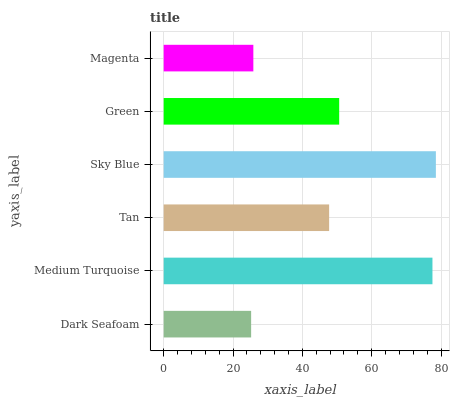Is Dark Seafoam the minimum?
Answer yes or no. Yes. Is Sky Blue the maximum?
Answer yes or no. Yes. Is Medium Turquoise the minimum?
Answer yes or no. No. Is Medium Turquoise the maximum?
Answer yes or no. No. Is Medium Turquoise greater than Dark Seafoam?
Answer yes or no. Yes. Is Dark Seafoam less than Medium Turquoise?
Answer yes or no. Yes. Is Dark Seafoam greater than Medium Turquoise?
Answer yes or no. No. Is Medium Turquoise less than Dark Seafoam?
Answer yes or no. No. Is Green the high median?
Answer yes or no. Yes. Is Tan the low median?
Answer yes or no. Yes. Is Sky Blue the high median?
Answer yes or no. No. Is Green the low median?
Answer yes or no. No. 